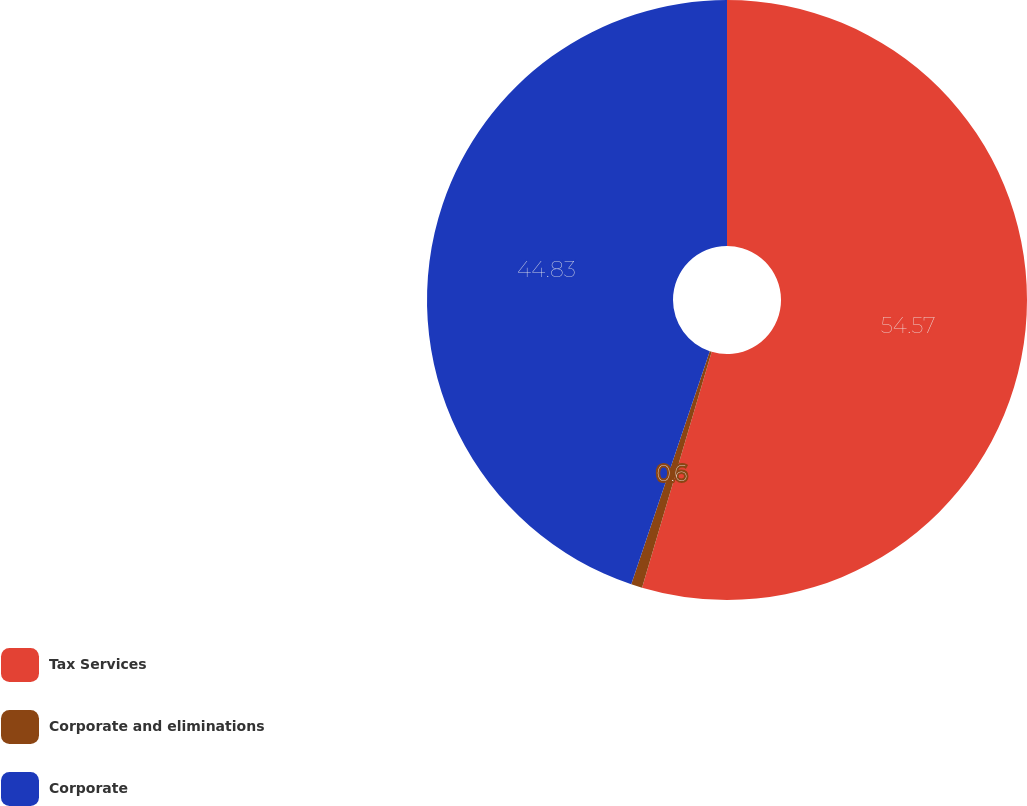<chart> <loc_0><loc_0><loc_500><loc_500><pie_chart><fcel>Tax Services<fcel>Corporate and eliminations<fcel>Corporate<nl><fcel>54.57%<fcel>0.6%<fcel>44.83%<nl></chart> 